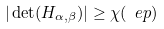Convert formula to latex. <formula><loc_0><loc_0><loc_500><loc_500>| \det ( H _ { \alpha , \beta } ) | \geq \chi ( \ e p )</formula> 